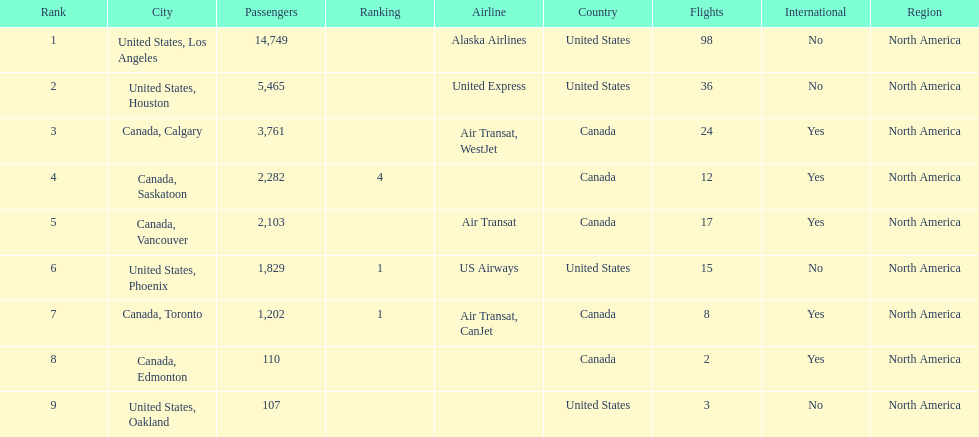What is the average number of passengers in the united states? 5537.5. 